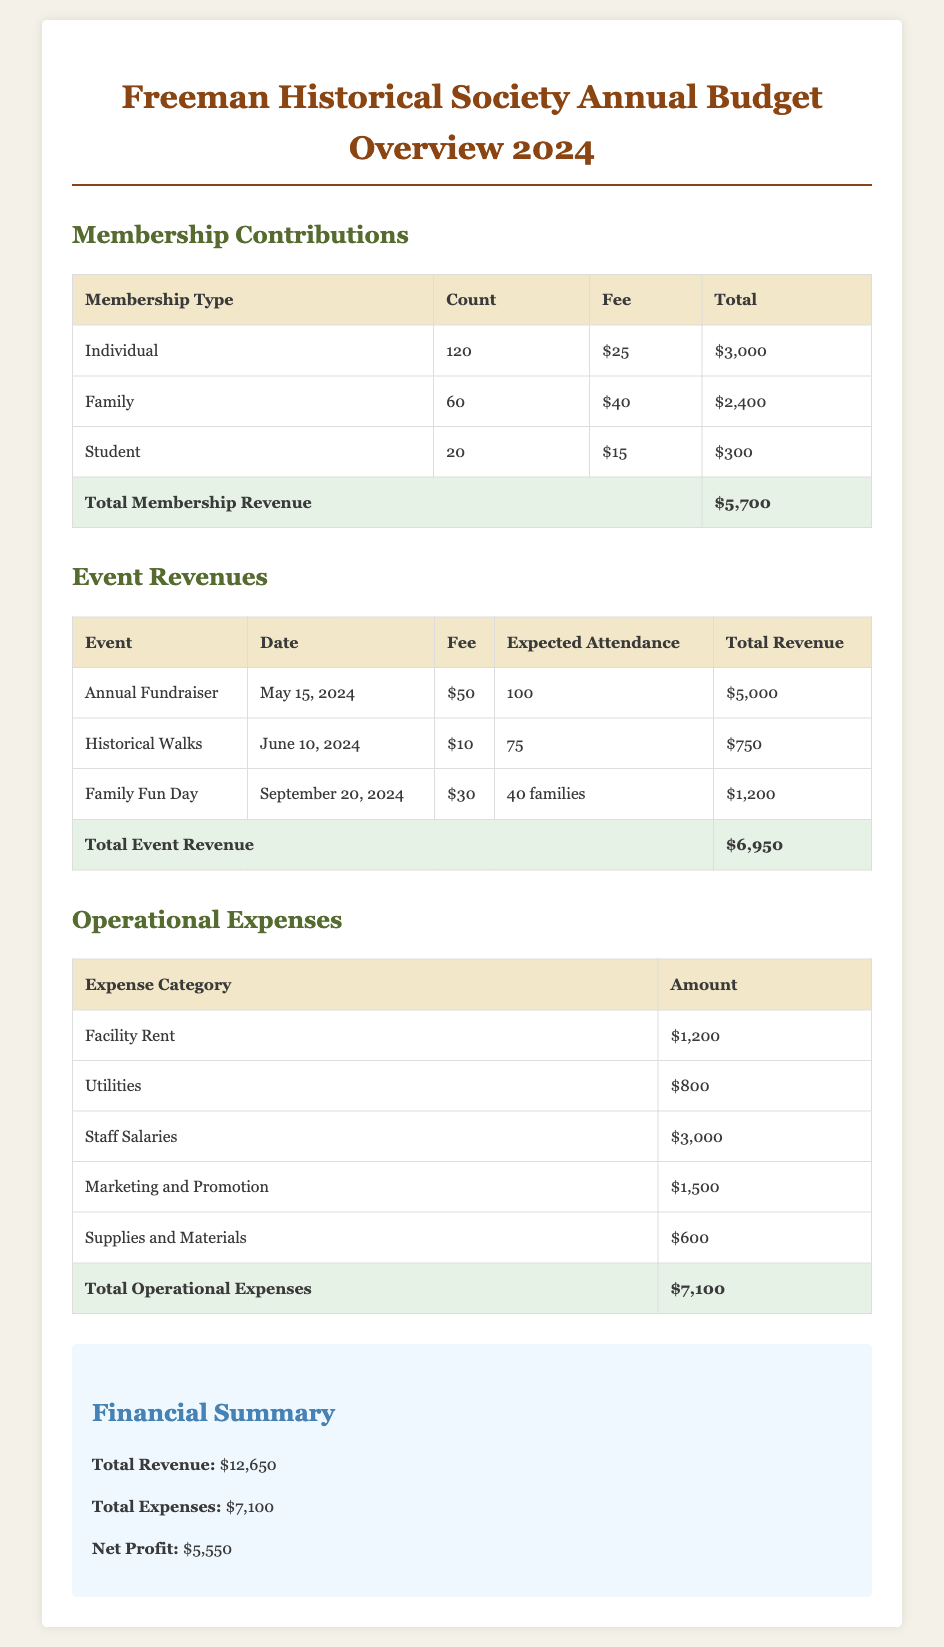what is the total membership revenue? The total membership revenue is the sum of all membership contributions listed in the document. Individual ($3,000) + Family ($2,400) + Student ($300) = $5,700.
Answer: $5,700 what is the expected attendance for the Annual Fundraiser? The expected attendance for the Annual Fundraiser is specified in the event revenues section of the document. It states that the expected attendance is 100.
Answer: 100 how much are staff salaries? Staff salaries are listed as one of the operational expenses in the document, which states the amount is $3,000.
Answer: $3,000 which event generates the highest revenue? The event revenues section shows that the Annual Fundraiser generates the highest revenue at $5,000.
Answer: Annual Fundraiser what is the net profit for the year? The net profit is calculated by subtracting total expenses from total revenue, both of which are provided in the financial summary section of the document. Total Revenue ($12,650) - Total Expenses ($7,100) = $5,550.
Answer: $5,550 what percentage of the total revenue comes from event revenues? The event revenue total of $6,950 divided by the total revenue of $12,650 provides the percentage of total revenue that comes from events. (6,950 / 12,650) * 100 = approximately 54.90%.
Answer: 54.90% how much does the Freeman Historical Society spend on utilities? Utilities are one of the operational expenses listed in the document, with an amount specified as $800.
Answer: $800 what type of membership has the highest count? The membership contributions section shows that the Individual membership type has the highest count at 120.
Answer: Individual 